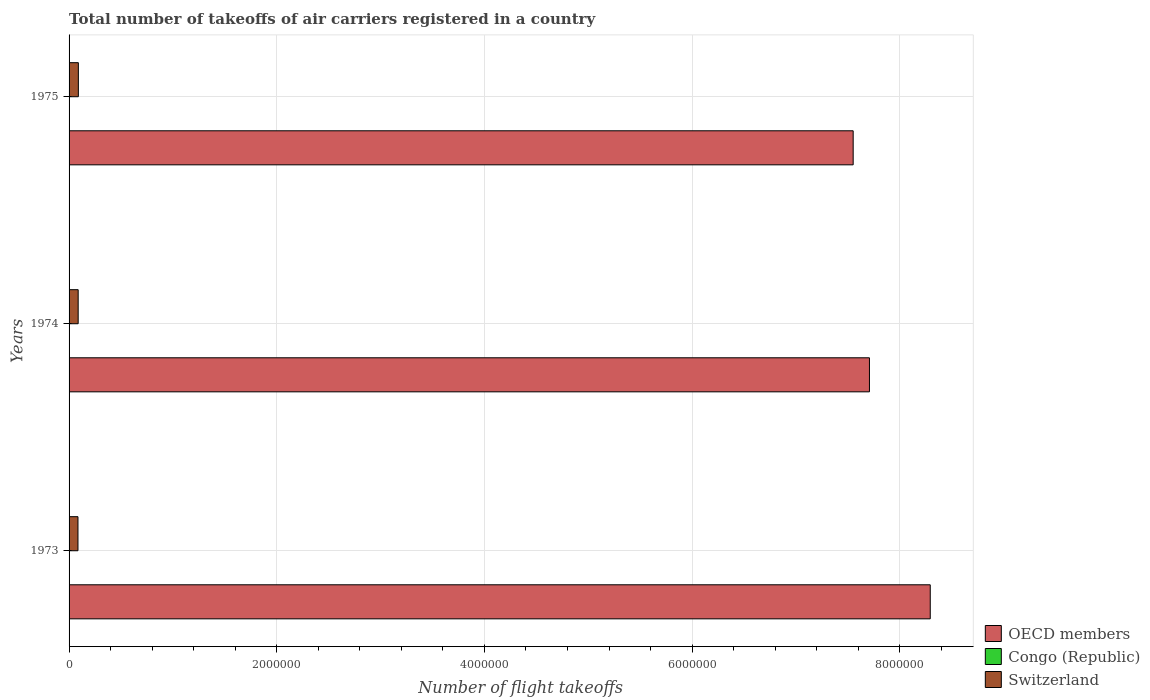Are the number of bars per tick equal to the number of legend labels?
Make the answer very short. Yes. How many bars are there on the 1st tick from the top?
Your response must be concise. 3. How many bars are there on the 3rd tick from the bottom?
Make the answer very short. 3. What is the label of the 1st group of bars from the top?
Ensure brevity in your answer.  1975. In how many cases, is the number of bars for a given year not equal to the number of legend labels?
Ensure brevity in your answer.  0. What is the total number of flight takeoffs in Congo (Republic) in 1973?
Ensure brevity in your answer.  3600. Across all years, what is the maximum total number of flight takeoffs in Switzerland?
Ensure brevity in your answer.  8.95e+04. Across all years, what is the minimum total number of flight takeoffs in Congo (Republic)?
Provide a succinct answer. 3600. In which year was the total number of flight takeoffs in Congo (Republic) maximum?
Keep it short and to the point. 1975. What is the total total number of flight takeoffs in OECD members in the graph?
Your answer should be compact. 2.36e+07. What is the difference between the total number of flight takeoffs in Congo (Republic) in 1974 and that in 1975?
Provide a short and direct response. -200. What is the difference between the total number of flight takeoffs in Switzerland in 1975 and the total number of flight takeoffs in OECD members in 1974?
Provide a succinct answer. -7.62e+06. What is the average total number of flight takeoffs in Switzerland per year?
Your answer should be very brief. 8.76e+04. In the year 1975, what is the difference between the total number of flight takeoffs in Congo (Republic) and total number of flight takeoffs in OECD members?
Give a very brief answer. -7.55e+06. In how many years, is the total number of flight takeoffs in Congo (Republic) greater than 5600000 ?
Provide a short and direct response. 0. What is the difference between the highest and the second highest total number of flight takeoffs in OECD members?
Your answer should be compact. 5.86e+05. What is the difference between the highest and the lowest total number of flight takeoffs in Congo (Republic)?
Offer a terse response. 200. Is the sum of the total number of flight takeoffs in Switzerland in 1973 and 1975 greater than the maximum total number of flight takeoffs in OECD members across all years?
Ensure brevity in your answer.  No. What does the 2nd bar from the top in 1975 represents?
Your answer should be very brief. Congo (Republic). What does the 3rd bar from the bottom in 1973 represents?
Provide a short and direct response. Switzerland. How many years are there in the graph?
Make the answer very short. 3. Are the values on the major ticks of X-axis written in scientific E-notation?
Offer a very short reply. No. Does the graph contain any zero values?
Your answer should be compact. No. Does the graph contain grids?
Make the answer very short. Yes. What is the title of the graph?
Offer a very short reply. Total number of takeoffs of air carriers registered in a country. Does "Mali" appear as one of the legend labels in the graph?
Provide a short and direct response. No. What is the label or title of the X-axis?
Offer a very short reply. Number of flight takeoffs. What is the Number of flight takeoffs in OECD members in 1973?
Keep it short and to the point. 8.29e+06. What is the Number of flight takeoffs in Congo (Republic) in 1973?
Give a very brief answer. 3600. What is the Number of flight takeoffs in Switzerland in 1973?
Offer a very short reply. 8.57e+04. What is the Number of flight takeoffs in OECD members in 1974?
Provide a short and direct response. 7.71e+06. What is the Number of flight takeoffs in Congo (Republic) in 1974?
Your answer should be very brief. 3600. What is the Number of flight takeoffs of Switzerland in 1974?
Ensure brevity in your answer.  8.77e+04. What is the Number of flight takeoffs in OECD members in 1975?
Offer a terse response. 7.55e+06. What is the Number of flight takeoffs of Congo (Republic) in 1975?
Offer a terse response. 3800. What is the Number of flight takeoffs of Switzerland in 1975?
Provide a succinct answer. 8.95e+04. Across all years, what is the maximum Number of flight takeoffs of OECD members?
Keep it short and to the point. 8.29e+06. Across all years, what is the maximum Number of flight takeoffs of Congo (Republic)?
Keep it short and to the point. 3800. Across all years, what is the maximum Number of flight takeoffs of Switzerland?
Provide a succinct answer. 8.95e+04. Across all years, what is the minimum Number of flight takeoffs in OECD members?
Your answer should be very brief. 7.55e+06. Across all years, what is the minimum Number of flight takeoffs of Congo (Republic)?
Offer a terse response. 3600. Across all years, what is the minimum Number of flight takeoffs of Switzerland?
Provide a succinct answer. 8.57e+04. What is the total Number of flight takeoffs in OECD members in the graph?
Provide a short and direct response. 2.36e+07. What is the total Number of flight takeoffs in Congo (Republic) in the graph?
Offer a terse response. 1.10e+04. What is the total Number of flight takeoffs in Switzerland in the graph?
Your answer should be very brief. 2.63e+05. What is the difference between the Number of flight takeoffs in OECD members in 1973 and that in 1974?
Your answer should be compact. 5.86e+05. What is the difference between the Number of flight takeoffs of Congo (Republic) in 1973 and that in 1974?
Ensure brevity in your answer.  0. What is the difference between the Number of flight takeoffs in Switzerland in 1973 and that in 1974?
Make the answer very short. -2000. What is the difference between the Number of flight takeoffs in OECD members in 1973 and that in 1975?
Your response must be concise. 7.42e+05. What is the difference between the Number of flight takeoffs of Congo (Republic) in 1973 and that in 1975?
Give a very brief answer. -200. What is the difference between the Number of flight takeoffs of Switzerland in 1973 and that in 1975?
Provide a short and direct response. -3800. What is the difference between the Number of flight takeoffs of OECD members in 1974 and that in 1975?
Give a very brief answer. 1.57e+05. What is the difference between the Number of flight takeoffs of Congo (Republic) in 1974 and that in 1975?
Give a very brief answer. -200. What is the difference between the Number of flight takeoffs of Switzerland in 1974 and that in 1975?
Offer a terse response. -1800. What is the difference between the Number of flight takeoffs in OECD members in 1973 and the Number of flight takeoffs in Congo (Republic) in 1974?
Offer a terse response. 8.29e+06. What is the difference between the Number of flight takeoffs in OECD members in 1973 and the Number of flight takeoffs in Switzerland in 1974?
Ensure brevity in your answer.  8.21e+06. What is the difference between the Number of flight takeoffs of Congo (Republic) in 1973 and the Number of flight takeoffs of Switzerland in 1974?
Ensure brevity in your answer.  -8.41e+04. What is the difference between the Number of flight takeoffs in OECD members in 1973 and the Number of flight takeoffs in Congo (Republic) in 1975?
Offer a very short reply. 8.29e+06. What is the difference between the Number of flight takeoffs in OECD members in 1973 and the Number of flight takeoffs in Switzerland in 1975?
Provide a short and direct response. 8.20e+06. What is the difference between the Number of flight takeoffs in Congo (Republic) in 1973 and the Number of flight takeoffs in Switzerland in 1975?
Your response must be concise. -8.59e+04. What is the difference between the Number of flight takeoffs of OECD members in 1974 and the Number of flight takeoffs of Congo (Republic) in 1975?
Provide a short and direct response. 7.70e+06. What is the difference between the Number of flight takeoffs of OECD members in 1974 and the Number of flight takeoffs of Switzerland in 1975?
Provide a short and direct response. 7.62e+06. What is the difference between the Number of flight takeoffs of Congo (Republic) in 1974 and the Number of flight takeoffs of Switzerland in 1975?
Ensure brevity in your answer.  -8.59e+04. What is the average Number of flight takeoffs of OECD members per year?
Give a very brief answer. 7.85e+06. What is the average Number of flight takeoffs in Congo (Republic) per year?
Your answer should be very brief. 3666.67. What is the average Number of flight takeoffs of Switzerland per year?
Offer a terse response. 8.76e+04. In the year 1973, what is the difference between the Number of flight takeoffs in OECD members and Number of flight takeoffs in Congo (Republic)?
Keep it short and to the point. 8.29e+06. In the year 1973, what is the difference between the Number of flight takeoffs in OECD members and Number of flight takeoffs in Switzerland?
Your answer should be compact. 8.21e+06. In the year 1973, what is the difference between the Number of flight takeoffs in Congo (Republic) and Number of flight takeoffs in Switzerland?
Make the answer very short. -8.21e+04. In the year 1974, what is the difference between the Number of flight takeoffs in OECD members and Number of flight takeoffs in Congo (Republic)?
Make the answer very short. 7.70e+06. In the year 1974, what is the difference between the Number of flight takeoffs of OECD members and Number of flight takeoffs of Switzerland?
Offer a terse response. 7.62e+06. In the year 1974, what is the difference between the Number of flight takeoffs of Congo (Republic) and Number of flight takeoffs of Switzerland?
Offer a very short reply. -8.41e+04. In the year 1975, what is the difference between the Number of flight takeoffs of OECD members and Number of flight takeoffs of Congo (Republic)?
Keep it short and to the point. 7.55e+06. In the year 1975, what is the difference between the Number of flight takeoffs in OECD members and Number of flight takeoffs in Switzerland?
Ensure brevity in your answer.  7.46e+06. In the year 1975, what is the difference between the Number of flight takeoffs of Congo (Republic) and Number of flight takeoffs of Switzerland?
Your answer should be compact. -8.57e+04. What is the ratio of the Number of flight takeoffs of OECD members in 1973 to that in 1974?
Your response must be concise. 1.08. What is the ratio of the Number of flight takeoffs in Congo (Republic) in 1973 to that in 1974?
Offer a terse response. 1. What is the ratio of the Number of flight takeoffs of Switzerland in 1973 to that in 1974?
Give a very brief answer. 0.98. What is the ratio of the Number of flight takeoffs of OECD members in 1973 to that in 1975?
Keep it short and to the point. 1.1. What is the ratio of the Number of flight takeoffs of Congo (Republic) in 1973 to that in 1975?
Provide a short and direct response. 0.95. What is the ratio of the Number of flight takeoffs of Switzerland in 1973 to that in 1975?
Offer a terse response. 0.96. What is the ratio of the Number of flight takeoffs in OECD members in 1974 to that in 1975?
Offer a very short reply. 1.02. What is the ratio of the Number of flight takeoffs in Congo (Republic) in 1974 to that in 1975?
Offer a very short reply. 0.95. What is the ratio of the Number of flight takeoffs of Switzerland in 1974 to that in 1975?
Your answer should be very brief. 0.98. What is the difference between the highest and the second highest Number of flight takeoffs in OECD members?
Your answer should be very brief. 5.86e+05. What is the difference between the highest and the second highest Number of flight takeoffs in Switzerland?
Keep it short and to the point. 1800. What is the difference between the highest and the lowest Number of flight takeoffs of OECD members?
Keep it short and to the point. 7.42e+05. What is the difference between the highest and the lowest Number of flight takeoffs of Switzerland?
Offer a terse response. 3800. 